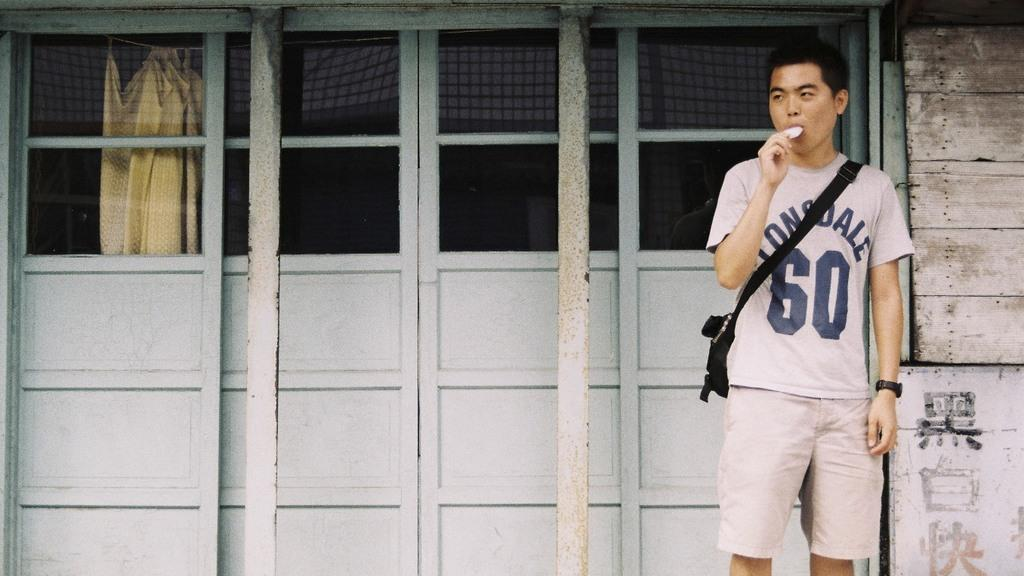<image>
Create a compact narrative representing the image presented. The guy in the picture has a number 60 on his shirt. 